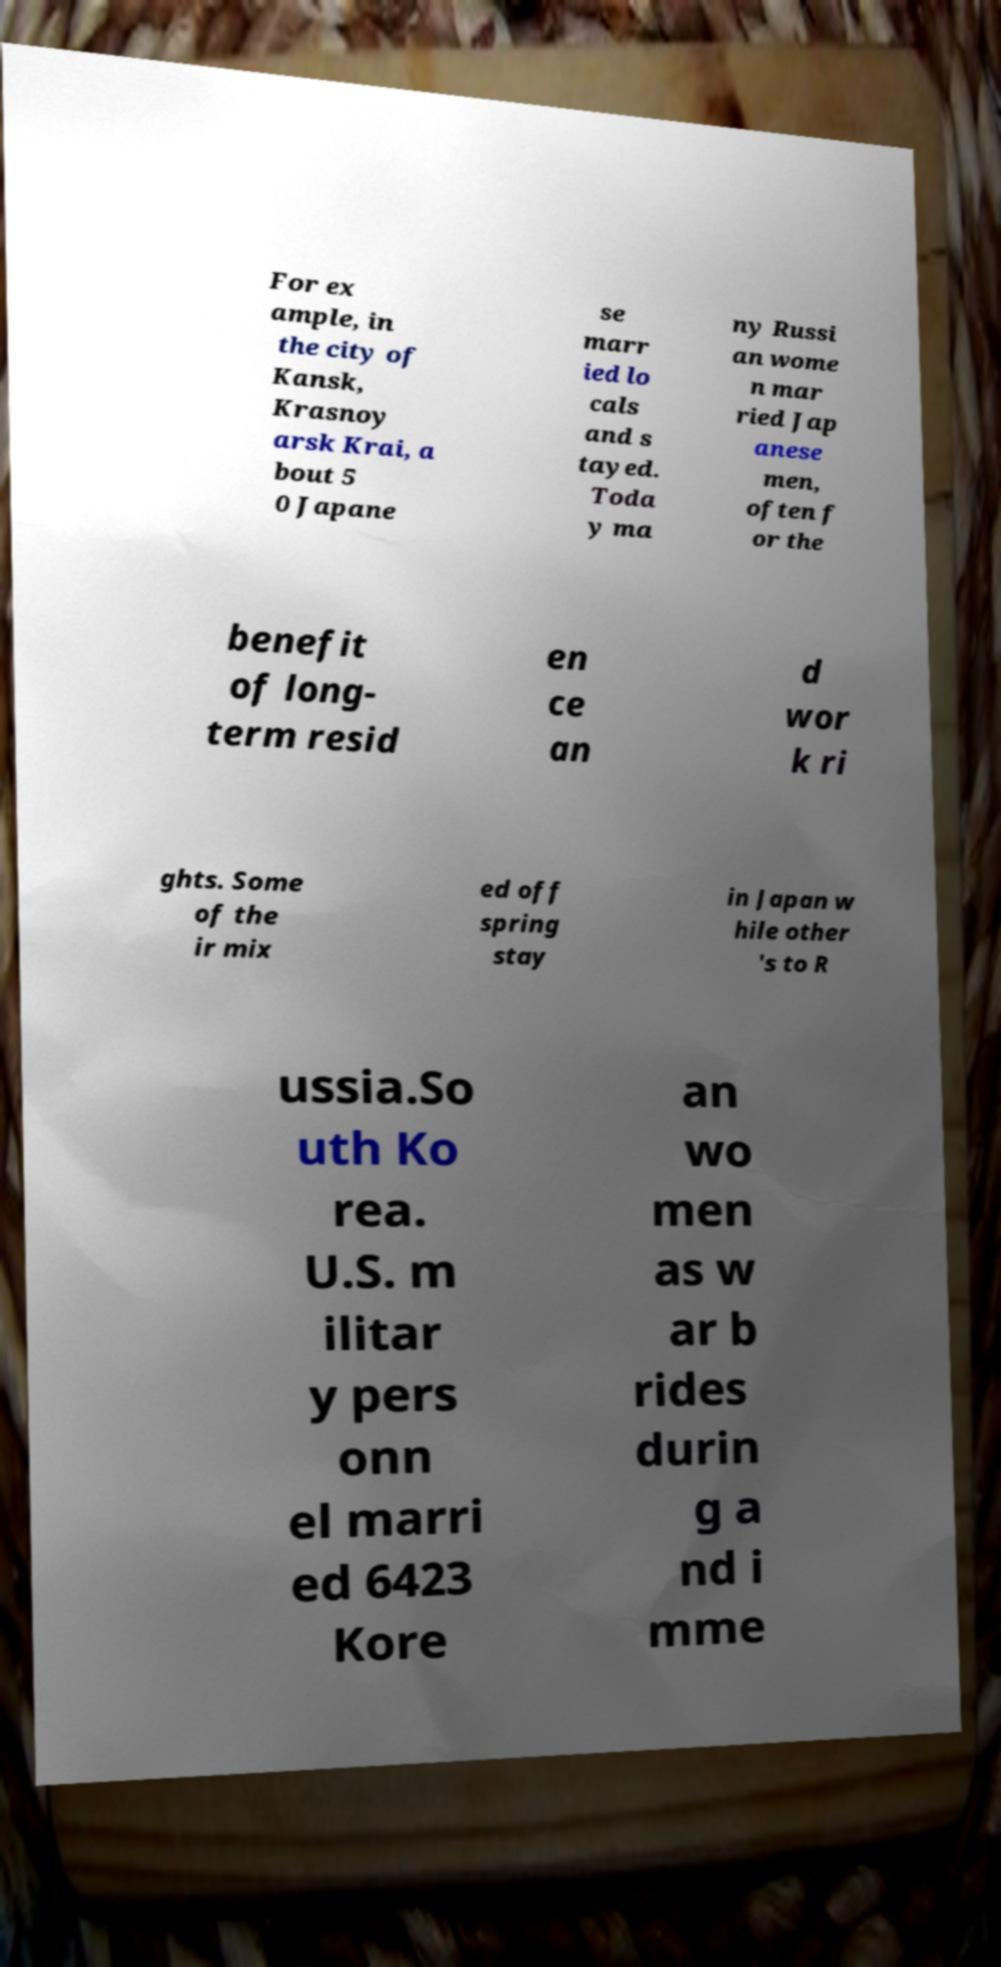What messages or text are displayed in this image? I need them in a readable, typed format. For ex ample, in the city of Kansk, Krasnoy arsk Krai, a bout 5 0 Japane se marr ied lo cals and s tayed. Toda y ma ny Russi an wome n mar ried Jap anese men, often f or the benefit of long- term resid en ce an d wor k ri ghts. Some of the ir mix ed off spring stay in Japan w hile other 's to R ussia.So uth Ko rea. U.S. m ilitar y pers onn el marri ed 6423 Kore an wo men as w ar b rides durin g a nd i mme 